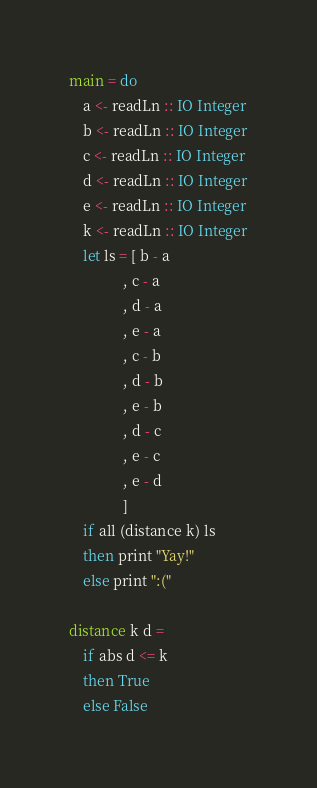Convert code to text. <code><loc_0><loc_0><loc_500><loc_500><_Haskell_>main = do
    a <- readLn :: IO Integer
    b <- readLn :: IO Integer
    c <- readLn :: IO Integer
    d <- readLn :: IO Integer
    e <- readLn :: IO Integer
    k <- readLn :: IO Integer
    let ls = [ b - a
               , c - a
               , d - a
               , e - a
               , c - b
               , d - b
               , e - b
               , d - c
               , e - c
               , e - d
               ]
    if all (distance k) ls
    then print "Yay!"
    else print ":("
    
distance k d =
    if abs d <= k
    then True
    else False
</code> 